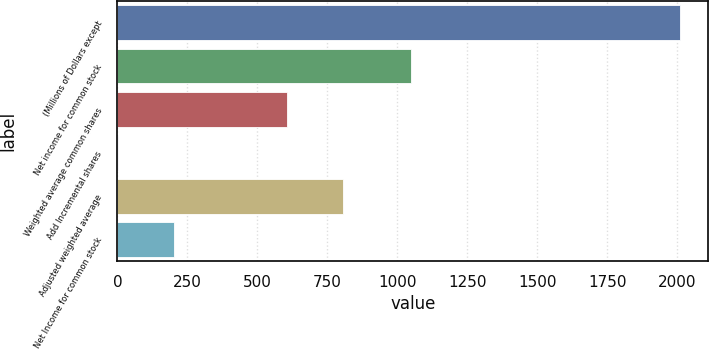<chart> <loc_0><loc_0><loc_500><loc_500><bar_chart><fcel>(Millions of Dollars except<fcel>Net income for common stock<fcel>Weighted average common shares<fcel>Add Incremental shares<fcel>Adjusted weighted average<fcel>Net Income for common stock<nl><fcel>2011<fcel>1051<fcel>604.56<fcel>1.8<fcel>805.48<fcel>202.72<nl></chart> 